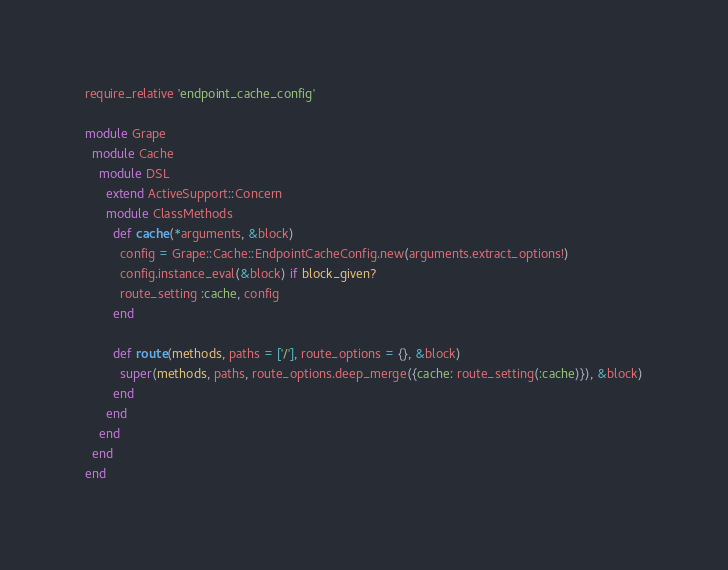Convert code to text. <code><loc_0><loc_0><loc_500><loc_500><_Ruby_>require_relative 'endpoint_cache_config'

module Grape
  module Cache
    module DSL
      extend ActiveSupport::Concern
      module ClassMethods
        def cache(*arguments, &block)
          config = Grape::Cache::EndpointCacheConfig.new(arguments.extract_options!)
          config.instance_eval(&block) if block_given?
          route_setting :cache, config
        end

        def route(methods, paths = ['/'], route_options = {}, &block)
          super(methods, paths, route_options.deep_merge({cache: route_setting(:cache)}), &block)
        end
      end
    end
  end
end
</code> 